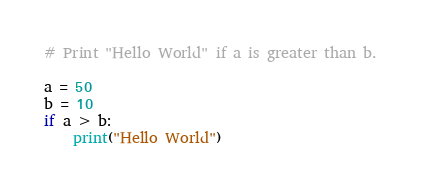<code> <loc_0><loc_0><loc_500><loc_500><_Python_># Print "Hello World" if a is greater than b.

a = 50
b = 10
if a > b:
    print("Hello World")
</code> 